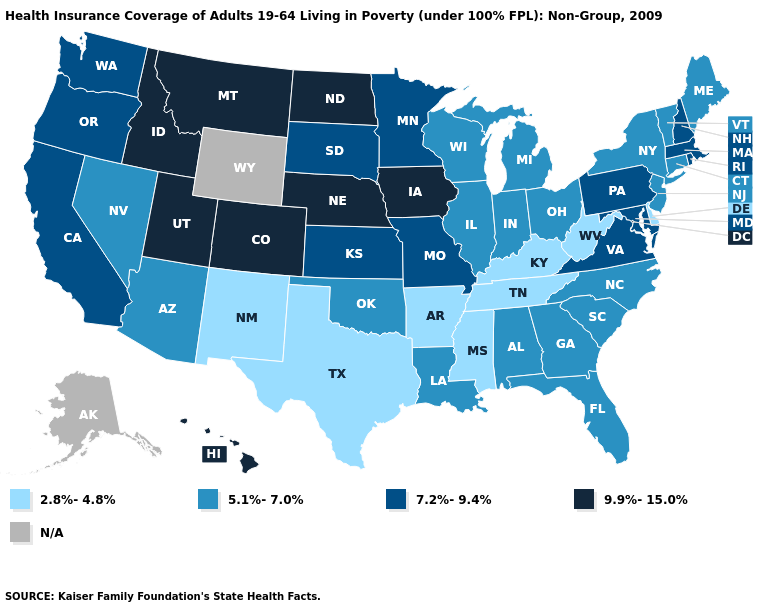What is the lowest value in the USA?
Quick response, please. 2.8%-4.8%. What is the lowest value in the South?
Write a very short answer. 2.8%-4.8%. What is the value of South Carolina?
Give a very brief answer. 5.1%-7.0%. Does Nebraska have the highest value in the MidWest?
Keep it brief. Yes. Name the states that have a value in the range N/A?
Keep it brief. Alaska, Wyoming. Name the states that have a value in the range 7.2%-9.4%?
Give a very brief answer. California, Kansas, Maryland, Massachusetts, Minnesota, Missouri, New Hampshire, Oregon, Pennsylvania, Rhode Island, South Dakota, Virginia, Washington. Does the first symbol in the legend represent the smallest category?
Answer briefly. Yes. Name the states that have a value in the range 5.1%-7.0%?
Write a very short answer. Alabama, Arizona, Connecticut, Florida, Georgia, Illinois, Indiana, Louisiana, Maine, Michigan, Nevada, New Jersey, New York, North Carolina, Ohio, Oklahoma, South Carolina, Vermont, Wisconsin. What is the lowest value in the USA?
Answer briefly. 2.8%-4.8%. What is the lowest value in the USA?
Short answer required. 2.8%-4.8%. What is the value of Tennessee?
Be succinct. 2.8%-4.8%. What is the lowest value in the USA?
Short answer required. 2.8%-4.8%. What is the value of Iowa?
Quick response, please. 9.9%-15.0%. Name the states that have a value in the range 9.9%-15.0%?
Be succinct. Colorado, Hawaii, Idaho, Iowa, Montana, Nebraska, North Dakota, Utah. 